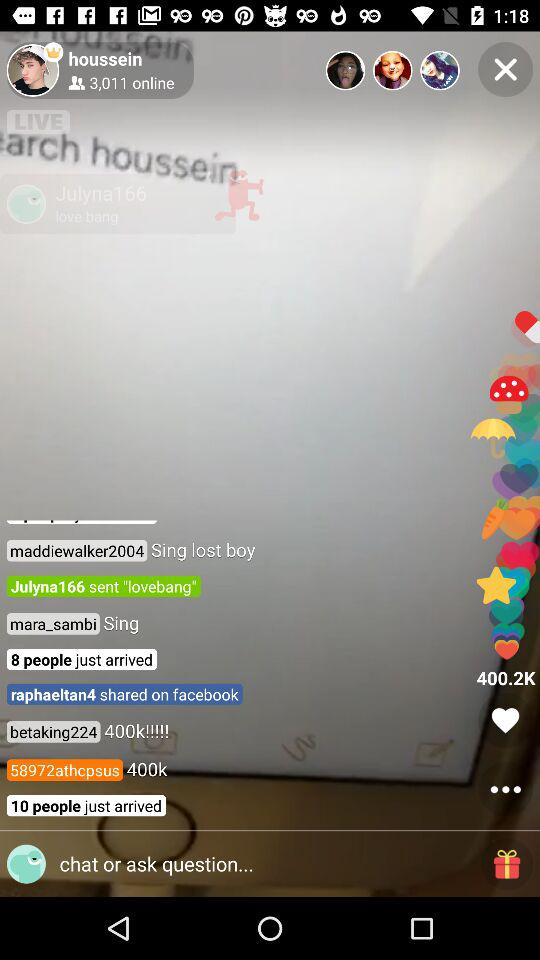How many people are online? There are 3,011 people online. 